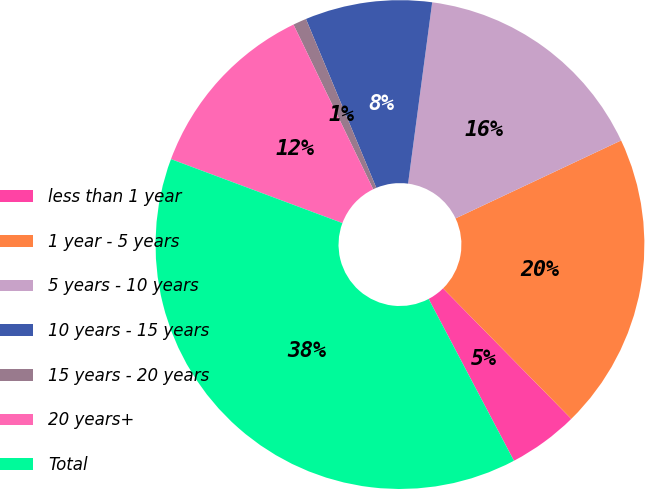Convert chart. <chart><loc_0><loc_0><loc_500><loc_500><pie_chart><fcel>less than 1 year<fcel>1 year - 5 years<fcel>5 years - 10 years<fcel>10 years - 15 years<fcel>15 years - 20 years<fcel>20 years+<fcel>Total<nl><fcel>4.64%<fcel>19.64%<fcel>15.89%<fcel>8.39%<fcel>0.89%<fcel>12.14%<fcel>38.4%<nl></chart> 